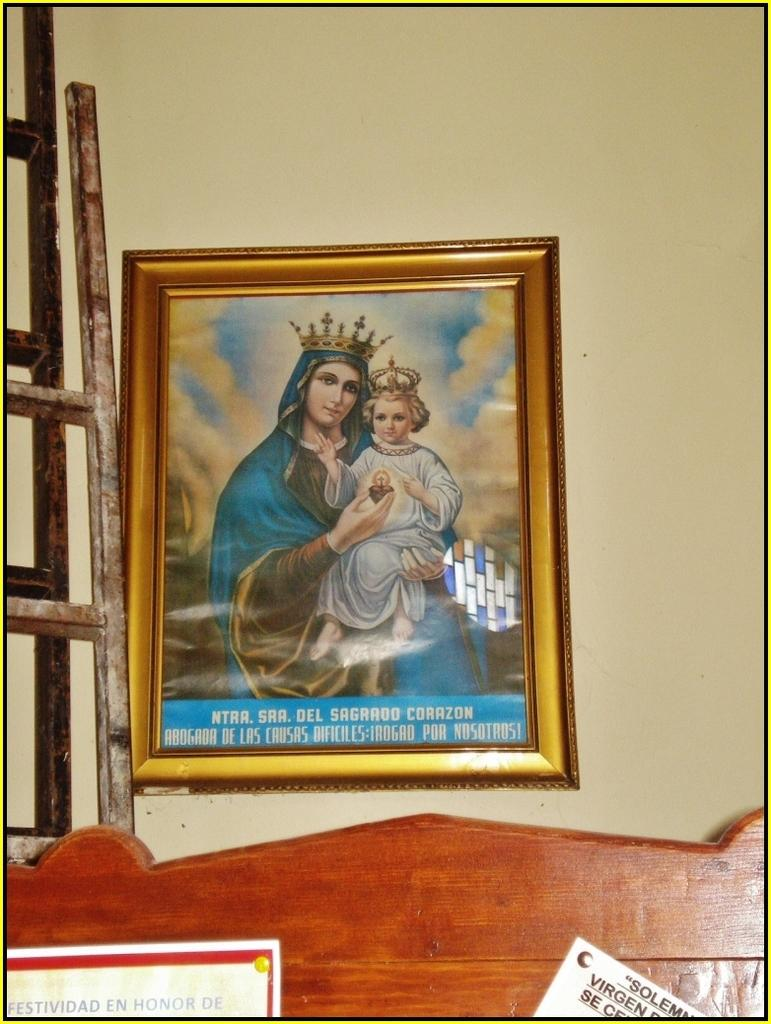<image>
Relay a brief, clear account of the picture shown. A portrait of the Virgin Mary and the baby Jesus is captioned with "Abogada de las Causas Dificiles: Irogad por Nosotros!" 